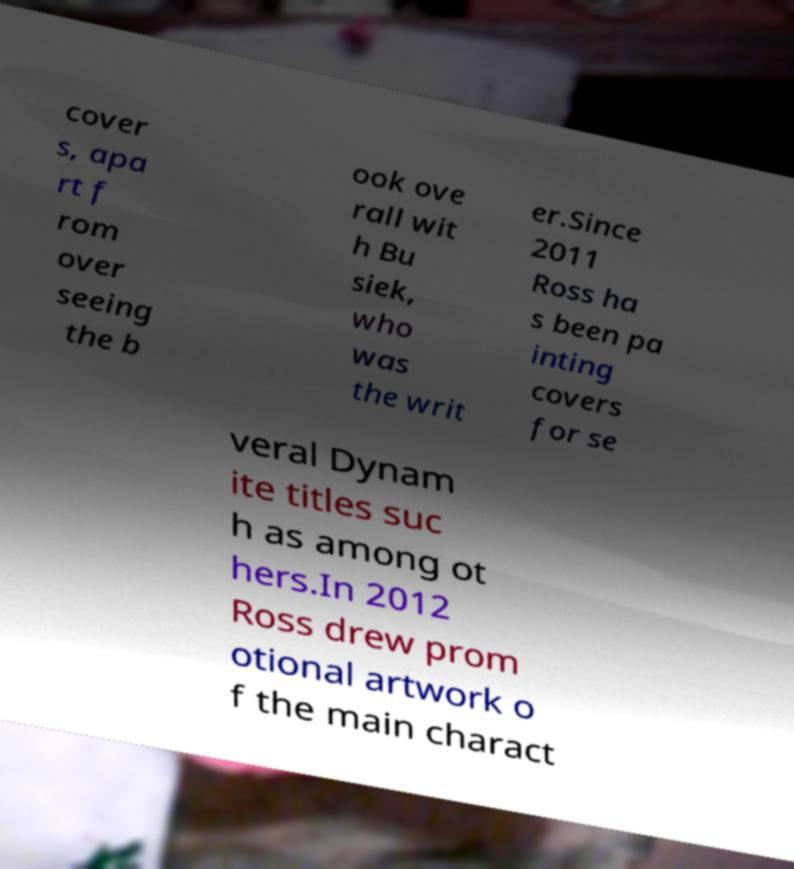Please identify and transcribe the text found in this image. cover s, apa rt f rom over seeing the b ook ove rall wit h Bu siek, who was the writ er.Since 2011 Ross ha s been pa inting covers for se veral Dynam ite titles suc h as among ot hers.In 2012 Ross drew prom otional artwork o f the main charact 